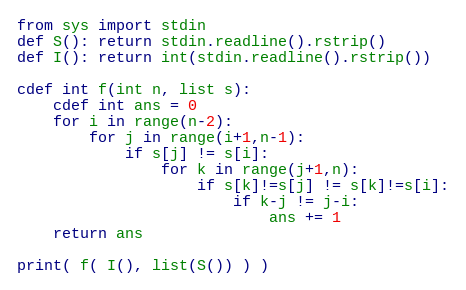Convert code to text. <code><loc_0><loc_0><loc_500><loc_500><_Cython_>from sys import stdin
def S(): return stdin.readline().rstrip()
def I(): return int(stdin.readline().rstrip())

cdef int f(int n, list s):
    cdef int ans = 0
    for i in range(n-2):
        for j in range(i+1,n-1):
            if s[j] != s[i]:
                for k in range(j+1,n):
                    if s[k]!=s[j] != s[k]!=s[i]:
                        if k-j != j-i:
                            ans += 1
    return ans

print( f( I(), list(S()) ) )</code> 